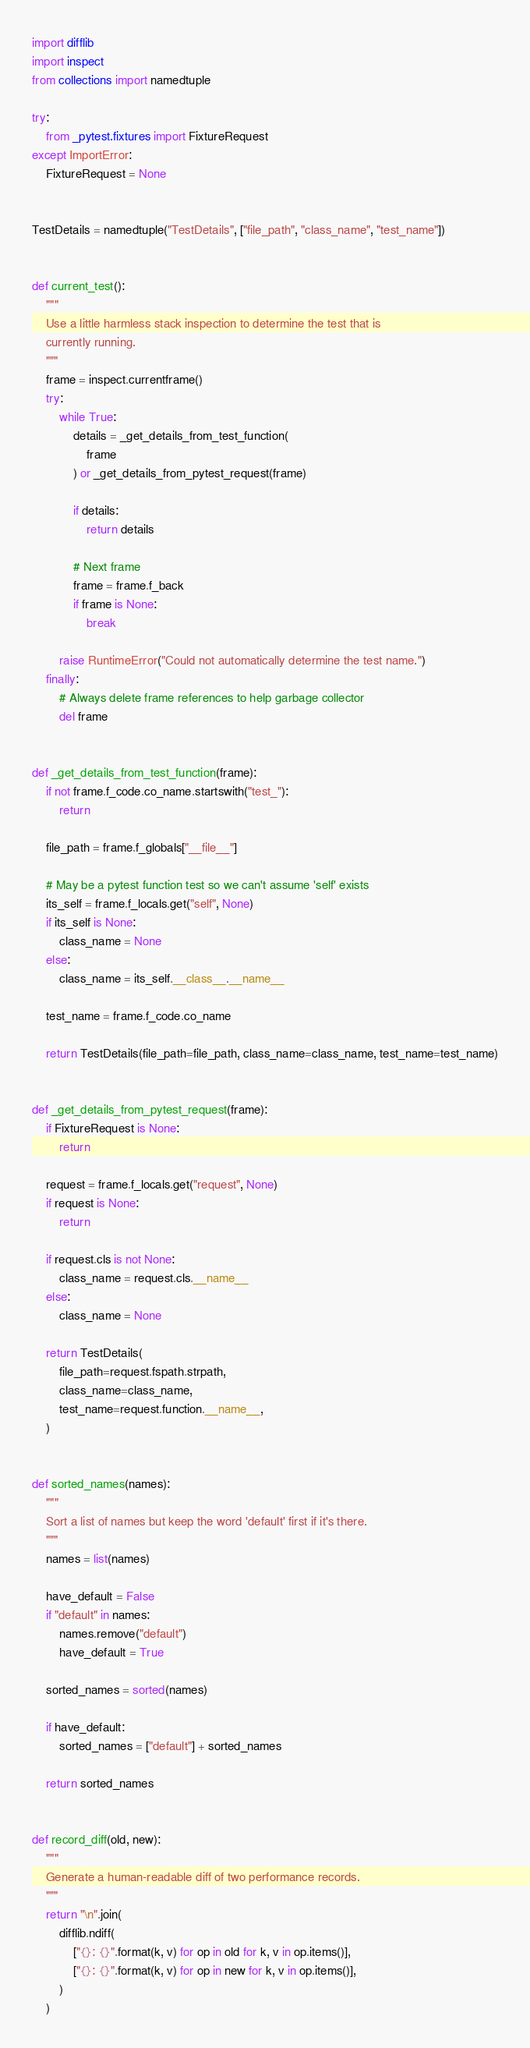<code> <loc_0><loc_0><loc_500><loc_500><_Python_>import difflib
import inspect
from collections import namedtuple

try:
    from _pytest.fixtures import FixtureRequest
except ImportError:
    FixtureRequest = None


TestDetails = namedtuple("TestDetails", ["file_path", "class_name", "test_name"])


def current_test():
    """
    Use a little harmless stack inspection to determine the test that is
    currently running.
    """
    frame = inspect.currentframe()
    try:
        while True:
            details = _get_details_from_test_function(
                frame
            ) or _get_details_from_pytest_request(frame)

            if details:
                return details

            # Next frame
            frame = frame.f_back
            if frame is None:
                break

        raise RuntimeError("Could not automatically determine the test name.")
    finally:
        # Always delete frame references to help garbage collector
        del frame


def _get_details_from_test_function(frame):
    if not frame.f_code.co_name.startswith("test_"):
        return

    file_path = frame.f_globals["__file__"]

    # May be a pytest function test so we can't assume 'self' exists
    its_self = frame.f_locals.get("self", None)
    if its_self is None:
        class_name = None
    else:
        class_name = its_self.__class__.__name__

    test_name = frame.f_code.co_name

    return TestDetails(file_path=file_path, class_name=class_name, test_name=test_name)


def _get_details_from_pytest_request(frame):
    if FixtureRequest is None:
        return

    request = frame.f_locals.get("request", None)
    if request is None:
        return

    if request.cls is not None:
        class_name = request.cls.__name__
    else:
        class_name = None

    return TestDetails(
        file_path=request.fspath.strpath,
        class_name=class_name,
        test_name=request.function.__name__,
    )


def sorted_names(names):
    """
    Sort a list of names but keep the word 'default' first if it's there.
    """
    names = list(names)

    have_default = False
    if "default" in names:
        names.remove("default")
        have_default = True

    sorted_names = sorted(names)

    if have_default:
        sorted_names = ["default"] + sorted_names

    return sorted_names


def record_diff(old, new):
    """
    Generate a human-readable diff of two performance records.
    """
    return "\n".join(
        difflib.ndiff(
            ["{}: {}".format(k, v) for op in old for k, v in op.items()],
            ["{}: {}".format(k, v) for op in new for k, v in op.items()],
        )
    )
</code> 